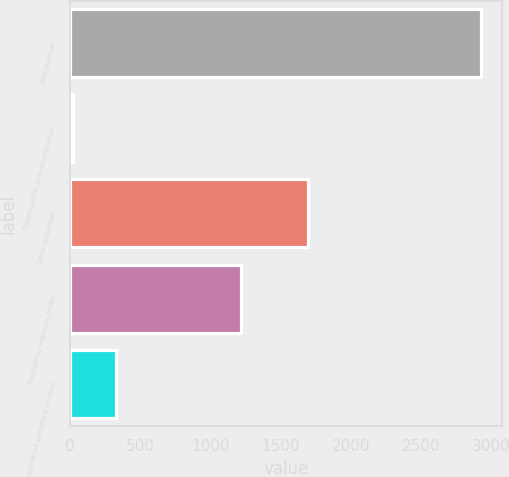<chart> <loc_0><loc_0><loc_500><loc_500><bar_chart><fcel>Net revenue<fcel>Depreciation and amortization<fcel>Other expenses<fcel>Publishing segment profit<fcel>Consolidated operating income<nl><fcel>2927<fcel>19<fcel>1690<fcel>1218<fcel>325<nl></chart> 